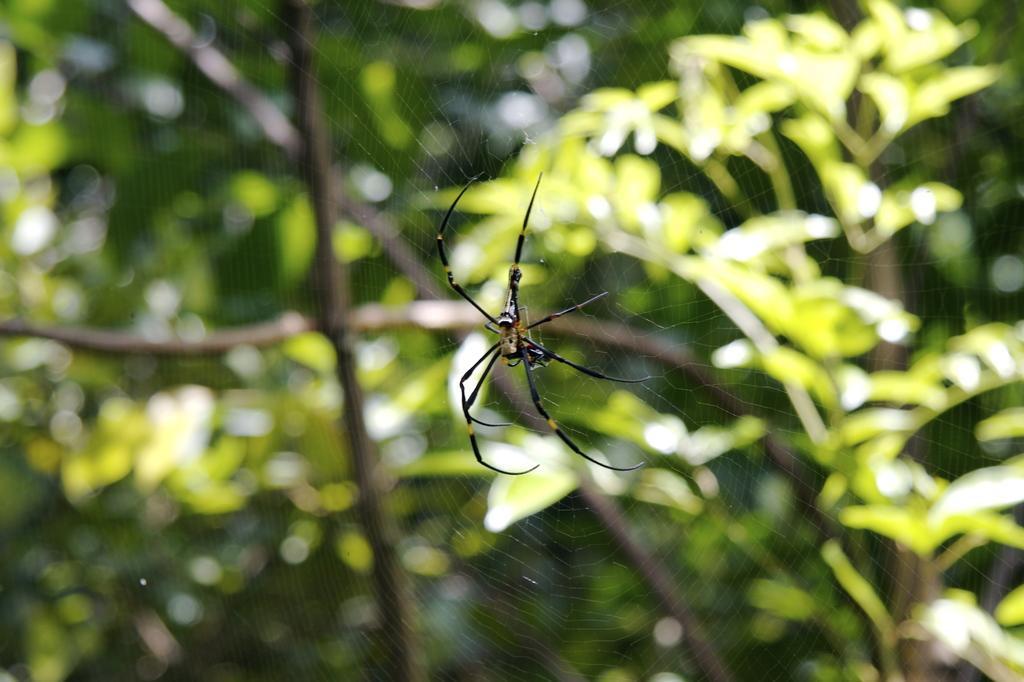Please provide a concise description of this image. In this picture there is a spider on a web in the center of the image and there are trees in the background area of the image. 